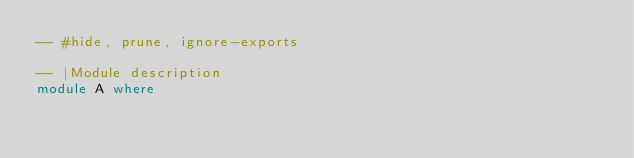<code> <loc_0><loc_0><loc_500><loc_500><_Haskell_>-- #hide, prune, ignore-exports

-- |Module description
module A where
</code> 